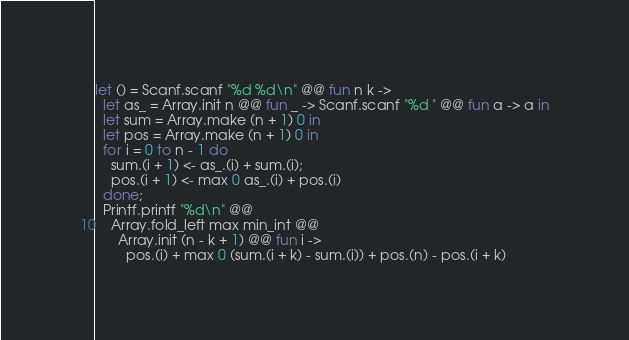Convert code to text. <code><loc_0><loc_0><loc_500><loc_500><_OCaml_>let () = Scanf.scanf "%d %d\n" @@ fun n k ->
  let as_ = Array.init n @@ fun _ -> Scanf.scanf "%d " @@ fun a -> a in
  let sum = Array.make (n + 1) 0 in
  let pos = Array.make (n + 1) 0 in
  for i = 0 to n - 1 do
    sum.(i + 1) <- as_.(i) + sum.(i);
    pos.(i + 1) <- max 0 as_.(i) + pos.(i)
  done;
  Printf.printf "%d\n" @@
    Array.fold_left max min_int @@
      Array.init (n - k + 1) @@ fun i ->
        pos.(i) + max 0 (sum.(i + k) - sum.(i)) + pos.(n) - pos.(i + k)
</code> 